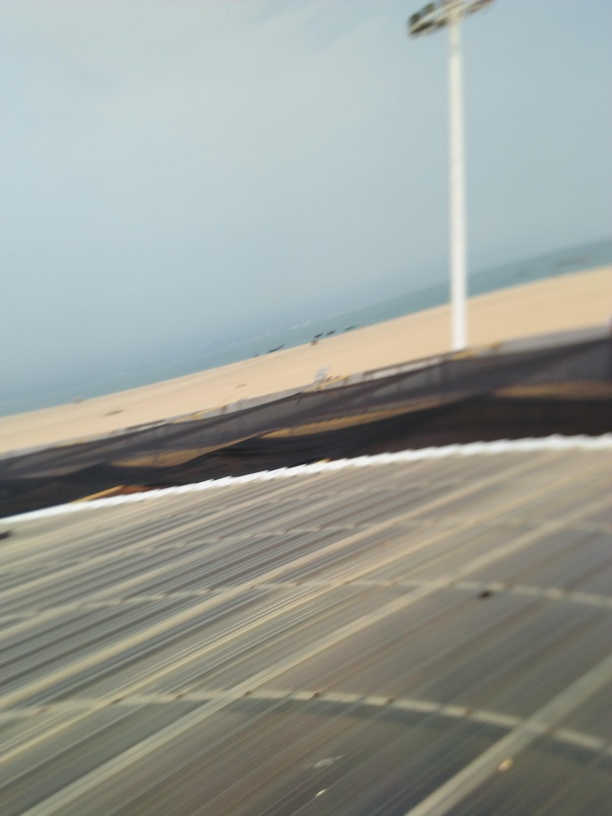How might the motion blur in this image affect the mood or atmosphere portrayed? The motion blur present in this image creates a sense of dynamism and fluidity, imparting an impression of movement and haste. It can evoke feelings of fleeting moments or the swift passage of time, giving the photograph a more spontaneous, perhaps even chaotic, character that can stand in contrast to the typically static and calm nature of beachscapes. 